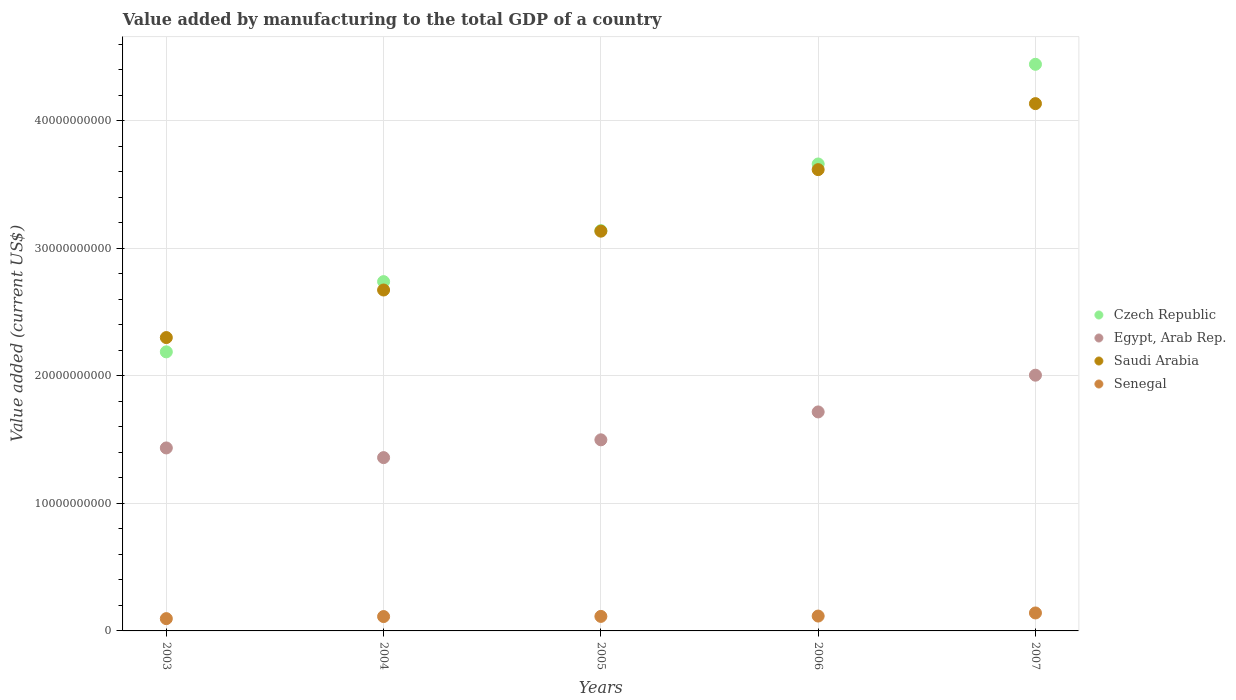What is the value added by manufacturing to the total GDP in Senegal in 2006?
Give a very brief answer. 1.17e+09. Across all years, what is the maximum value added by manufacturing to the total GDP in Senegal?
Provide a short and direct response. 1.41e+09. Across all years, what is the minimum value added by manufacturing to the total GDP in Czech Republic?
Make the answer very short. 2.19e+1. In which year was the value added by manufacturing to the total GDP in Czech Republic minimum?
Ensure brevity in your answer.  2003. What is the total value added by manufacturing to the total GDP in Senegal in the graph?
Offer a terse response. 5.80e+09. What is the difference between the value added by manufacturing to the total GDP in Saudi Arabia in 2003 and that in 2006?
Provide a succinct answer. -1.32e+1. What is the difference between the value added by manufacturing to the total GDP in Senegal in 2006 and the value added by manufacturing to the total GDP in Czech Republic in 2005?
Your answer should be compact. -3.02e+1. What is the average value added by manufacturing to the total GDP in Egypt, Arab Rep. per year?
Make the answer very short. 1.60e+1. In the year 2004, what is the difference between the value added by manufacturing to the total GDP in Egypt, Arab Rep. and value added by manufacturing to the total GDP in Czech Republic?
Your answer should be compact. -1.38e+1. In how many years, is the value added by manufacturing to the total GDP in Saudi Arabia greater than 30000000000 US$?
Your answer should be very brief. 3. What is the ratio of the value added by manufacturing to the total GDP in Egypt, Arab Rep. in 2005 to that in 2007?
Offer a very short reply. 0.75. Is the value added by manufacturing to the total GDP in Czech Republic in 2003 less than that in 2005?
Give a very brief answer. Yes. Is the difference between the value added by manufacturing to the total GDP in Egypt, Arab Rep. in 2004 and 2005 greater than the difference between the value added by manufacturing to the total GDP in Czech Republic in 2004 and 2005?
Offer a terse response. Yes. What is the difference between the highest and the second highest value added by manufacturing to the total GDP in Senegal?
Your response must be concise. 2.43e+08. What is the difference between the highest and the lowest value added by manufacturing to the total GDP in Saudi Arabia?
Your response must be concise. 1.83e+1. In how many years, is the value added by manufacturing to the total GDP in Saudi Arabia greater than the average value added by manufacturing to the total GDP in Saudi Arabia taken over all years?
Offer a terse response. 2. Is the sum of the value added by manufacturing to the total GDP in Senegal in 2003 and 2004 greater than the maximum value added by manufacturing to the total GDP in Egypt, Arab Rep. across all years?
Keep it short and to the point. No. Does the value added by manufacturing to the total GDP in Senegal monotonically increase over the years?
Your answer should be compact. Yes. Is the value added by manufacturing to the total GDP in Saudi Arabia strictly greater than the value added by manufacturing to the total GDP in Czech Republic over the years?
Give a very brief answer. No. Is the value added by manufacturing to the total GDP in Czech Republic strictly less than the value added by manufacturing to the total GDP in Saudi Arabia over the years?
Provide a short and direct response. No. Are the values on the major ticks of Y-axis written in scientific E-notation?
Provide a succinct answer. No. Does the graph contain any zero values?
Offer a very short reply. No. Does the graph contain grids?
Keep it short and to the point. Yes. Where does the legend appear in the graph?
Give a very brief answer. Center right. How are the legend labels stacked?
Keep it short and to the point. Vertical. What is the title of the graph?
Keep it short and to the point. Value added by manufacturing to the total GDP of a country. What is the label or title of the X-axis?
Provide a short and direct response. Years. What is the label or title of the Y-axis?
Make the answer very short. Value added (current US$). What is the Value added (current US$) of Czech Republic in 2003?
Your answer should be compact. 2.19e+1. What is the Value added (current US$) of Egypt, Arab Rep. in 2003?
Offer a terse response. 1.43e+1. What is the Value added (current US$) of Saudi Arabia in 2003?
Offer a terse response. 2.30e+1. What is the Value added (current US$) in Senegal in 2003?
Your response must be concise. 9.63e+08. What is the Value added (current US$) in Czech Republic in 2004?
Your response must be concise. 2.74e+1. What is the Value added (current US$) in Egypt, Arab Rep. in 2004?
Give a very brief answer. 1.36e+1. What is the Value added (current US$) in Saudi Arabia in 2004?
Provide a succinct answer. 2.67e+1. What is the Value added (current US$) in Senegal in 2004?
Provide a succinct answer. 1.13e+09. What is the Value added (current US$) of Czech Republic in 2005?
Keep it short and to the point. 3.14e+1. What is the Value added (current US$) in Egypt, Arab Rep. in 2005?
Your response must be concise. 1.50e+1. What is the Value added (current US$) in Saudi Arabia in 2005?
Provide a short and direct response. 3.13e+1. What is the Value added (current US$) in Senegal in 2005?
Ensure brevity in your answer.  1.14e+09. What is the Value added (current US$) of Czech Republic in 2006?
Offer a very short reply. 3.66e+1. What is the Value added (current US$) in Egypt, Arab Rep. in 2006?
Provide a succinct answer. 1.72e+1. What is the Value added (current US$) of Saudi Arabia in 2006?
Keep it short and to the point. 3.62e+1. What is the Value added (current US$) of Senegal in 2006?
Make the answer very short. 1.17e+09. What is the Value added (current US$) of Czech Republic in 2007?
Offer a very short reply. 4.44e+1. What is the Value added (current US$) in Egypt, Arab Rep. in 2007?
Keep it short and to the point. 2.01e+1. What is the Value added (current US$) in Saudi Arabia in 2007?
Your answer should be compact. 4.13e+1. What is the Value added (current US$) of Senegal in 2007?
Provide a short and direct response. 1.41e+09. Across all years, what is the maximum Value added (current US$) in Czech Republic?
Provide a short and direct response. 4.44e+1. Across all years, what is the maximum Value added (current US$) in Egypt, Arab Rep.?
Give a very brief answer. 2.01e+1. Across all years, what is the maximum Value added (current US$) in Saudi Arabia?
Your response must be concise. 4.13e+1. Across all years, what is the maximum Value added (current US$) of Senegal?
Keep it short and to the point. 1.41e+09. Across all years, what is the minimum Value added (current US$) in Czech Republic?
Make the answer very short. 2.19e+1. Across all years, what is the minimum Value added (current US$) of Egypt, Arab Rep.?
Give a very brief answer. 1.36e+1. Across all years, what is the minimum Value added (current US$) in Saudi Arabia?
Offer a very short reply. 2.30e+1. Across all years, what is the minimum Value added (current US$) in Senegal?
Your answer should be very brief. 9.63e+08. What is the total Value added (current US$) in Czech Republic in the graph?
Offer a terse response. 1.62e+11. What is the total Value added (current US$) in Egypt, Arab Rep. in the graph?
Your response must be concise. 8.02e+1. What is the total Value added (current US$) in Saudi Arabia in the graph?
Your answer should be compact. 1.59e+11. What is the total Value added (current US$) of Senegal in the graph?
Your answer should be very brief. 5.80e+09. What is the difference between the Value added (current US$) in Czech Republic in 2003 and that in 2004?
Make the answer very short. -5.51e+09. What is the difference between the Value added (current US$) of Egypt, Arab Rep. in 2003 and that in 2004?
Keep it short and to the point. 7.59e+08. What is the difference between the Value added (current US$) in Saudi Arabia in 2003 and that in 2004?
Provide a succinct answer. -3.73e+09. What is the difference between the Value added (current US$) of Senegal in 2003 and that in 2004?
Your answer should be very brief. -1.63e+08. What is the difference between the Value added (current US$) of Czech Republic in 2003 and that in 2005?
Offer a very short reply. -9.51e+09. What is the difference between the Value added (current US$) of Egypt, Arab Rep. in 2003 and that in 2005?
Offer a very short reply. -6.37e+08. What is the difference between the Value added (current US$) in Saudi Arabia in 2003 and that in 2005?
Your answer should be compact. -8.34e+09. What is the difference between the Value added (current US$) in Senegal in 2003 and that in 2005?
Your response must be concise. -1.75e+08. What is the difference between the Value added (current US$) of Czech Republic in 2003 and that in 2006?
Give a very brief answer. -1.47e+1. What is the difference between the Value added (current US$) of Egypt, Arab Rep. in 2003 and that in 2006?
Your answer should be compact. -2.82e+09. What is the difference between the Value added (current US$) in Saudi Arabia in 2003 and that in 2006?
Make the answer very short. -1.32e+1. What is the difference between the Value added (current US$) of Senegal in 2003 and that in 2006?
Your answer should be very brief. -2.03e+08. What is the difference between the Value added (current US$) of Czech Republic in 2003 and that in 2007?
Your response must be concise. -2.26e+1. What is the difference between the Value added (current US$) of Egypt, Arab Rep. in 2003 and that in 2007?
Provide a short and direct response. -5.71e+09. What is the difference between the Value added (current US$) of Saudi Arabia in 2003 and that in 2007?
Ensure brevity in your answer.  -1.83e+1. What is the difference between the Value added (current US$) in Senegal in 2003 and that in 2007?
Your answer should be compact. -4.45e+08. What is the difference between the Value added (current US$) of Czech Republic in 2004 and that in 2005?
Ensure brevity in your answer.  -4.00e+09. What is the difference between the Value added (current US$) of Egypt, Arab Rep. in 2004 and that in 2005?
Offer a terse response. -1.40e+09. What is the difference between the Value added (current US$) in Saudi Arabia in 2004 and that in 2005?
Provide a succinct answer. -4.61e+09. What is the difference between the Value added (current US$) of Senegal in 2004 and that in 2005?
Give a very brief answer. -1.24e+07. What is the difference between the Value added (current US$) of Czech Republic in 2004 and that in 2006?
Offer a very short reply. -9.23e+09. What is the difference between the Value added (current US$) of Egypt, Arab Rep. in 2004 and that in 2006?
Make the answer very short. -3.58e+09. What is the difference between the Value added (current US$) in Saudi Arabia in 2004 and that in 2006?
Give a very brief answer. -9.44e+09. What is the difference between the Value added (current US$) of Senegal in 2004 and that in 2006?
Provide a succinct answer. -3.95e+07. What is the difference between the Value added (current US$) of Czech Republic in 2004 and that in 2007?
Give a very brief answer. -1.70e+1. What is the difference between the Value added (current US$) in Egypt, Arab Rep. in 2004 and that in 2007?
Offer a very short reply. -6.46e+09. What is the difference between the Value added (current US$) in Saudi Arabia in 2004 and that in 2007?
Make the answer very short. -1.46e+1. What is the difference between the Value added (current US$) of Senegal in 2004 and that in 2007?
Make the answer very short. -2.82e+08. What is the difference between the Value added (current US$) in Czech Republic in 2005 and that in 2006?
Offer a terse response. -5.23e+09. What is the difference between the Value added (current US$) of Egypt, Arab Rep. in 2005 and that in 2006?
Offer a terse response. -2.19e+09. What is the difference between the Value added (current US$) of Saudi Arabia in 2005 and that in 2006?
Your answer should be very brief. -4.83e+09. What is the difference between the Value added (current US$) in Senegal in 2005 and that in 2006?
Keep it short and to the point. -2.71e+07. What is the difference between the Value added (current US$) in Czech Republic in 2005 and that in 2007?
Make the answer very short. -1.30e+1. What is the difference between the Value added (current US$) in Egypt, Arab Rep. in 2005 and that in 2007?
Offer a very short reply. -5.07e+09. What is the difference between the Value added (current US$) in Saudi Arabia in 2005 and that in 2007?
Keep it short and to the point. -1.00e+1. What is the difference between the Value added (current US$) of Senegal in 2005 and that in 2007?
Offer a very short reply. -2.70e+08. What is the difference between the Value added (current US$) of Czech Republic in 2006 and that in 2007?
Your answer should be compact. -7.82e+09. What is the difference between the Value added (current US$) in Egypt, Arab Rep. in 2006 and that in 2007?
Your answer should be compact. -2.88e+09. What is the difference between the Value added (current US$) in Saudi Arabia in 2006 and that in 2007?
Keep it short and to the point. -5.18e+09. What is the difference between the Value added (current US$) in Senegal in 2006 and that in 2007?
Provide a succinct answer. -2.43e+08. What is the difference between the Value added (current US$) of Czech Republic in 2003 and the Value added (current US$) of Egypt, Arab Rep. in 2004?
Your response must be concise. 8.29e+09. What is the difference between the Value added (current US$) of Czech Republic in 2003 and the Value added (current US$) of Saudi Arabia in 2004?
Ensure brevity in your answer.  -4.85e+09. What is the difference between the Value added (current US$) in Czech Republic in 2003 and the Value added (current US$) in Senegal in 2004?
Ensure brevity in your answer.  2.08e+1. What is the difference between the Value added (current US$) in Egypt, Arab Rep. in 2003 and the Value added (current US$) in Saudi Arabia in 2004?
Ensure brevity in your answer.  -1.24e+1. What is the difference between the Value added (current US$) in Egypt, Arab Rep. in 2003 and the Value added (current US$) in Senegal in 2004?
Keep it short and to the point. 1.32e+1. What is the difference between the Value added (current US$) of Saudi Arabia in 2003 and the Value added (current US$) of Senegal in 2004?
Ensure brevity in your answer.  2.19e+1. What is the difference between the Value added (current US$) in Czech Republic in 2003 and the Value added (current US$) in Egypt, Arab Rep. in 2005?
Provide a succinct answer. 6.90e+09. What is the difference between the Value added (current US$) in Czech Republic in 2003 and the Value added (current US$) in Saudi Arabia in 2005?
Provide a succinct answer. -9.47e+09. What is the difference between the Value added (current US$) in Czech Republic in 2003 and the Value added (current US$) in Senegal in 2005?
Your answer should be very brief. 2.07e+1. What is the difference between the Value added (current US$) of Egypt, Arab Rep. in 2003 and the Value added (current US$) of Saudi Arabia in 2005?
Your response must be concise. -1.70e+1. What is the difference between the Value added (current US$) in Egypt, Arab Rep. in 2003 and the Value added (current US$) in Senegal in 2005?
Provide a short and direct response. 1.32e+1. What is the difference between the Value added (current US$) in Saudi Arabia in 2003 and the Value added (current US$) in Senegal in 2005?
Offer a terse response. 2.19e+1. What is the difference between the Value added (current US$) in Czech Republic in 2003 and the Value added (current US$) in Egypt, Arab Rep. in 2006?
Offer a very short reply. 4.71e+09. What is the difference between the Value added (current US$) in Czech Republic in 2003 and the Value added (current US$) in Saudi Arabia in 2006?
Ensure brevity in your answer.  -1.43e+1. What is the difference between the Value added (current US$) of Czech Republic in 2003 and the Value added (current US$) of Senegal in 2006?
Provide a short and direct response. 2.07e+1. What is the difference between the Value added (current US$) in Egypt, Arab Rep. in 2003 and the Value added (current US$) in Saudi Arabia in 2006?
Keep it short and to the point. -2.18e+1. What is the difference between the Value added (current US$) in Egypt, Arab Rep. in 2003 and the Value added (current US$) in Senegal in 2006?
Your answer should be very brief. 1.32e+1. What is the difference between the Value added (current US$) in Saudi Arabia in 2003 and the Value added (current US$) in Senegal in 2006?
Your response must be concise. 2.18e+1. What is the difference between the Value added (current US$) of Czech Republic in 2003 and the Value added (current US$) of Egypt, Arab Rep. in 2007?
Your response must be concise. 1.83e+09. What is the difference between the Value added (current US$) in Czech Republic in 2003 and the Value added (current US$) in Saudi Arabia in 2007?
Provide a succinct answer. -1.95e+1. What is the difference between the Value added (current US$) of Czech Republic in 2003 and the Value added (current US$) of Senegal in 2007?
Make the answer very short. 2.05e+1. What is the difference between the Value added (current US$) of Egypt, Arab Rep. in 2003 and the Value added (current US$) of Saudi Arabia in 2007?
Ensure brevity in your answer.  -2.70e+1. What is the difference between the Value added (current US$) in Egypt, Arab Rep. in 2003 and the Value added (current US$) in Senegal in 2007?
Provide a short and direct response. 1.29e+1. What is the difference between the Value added (current US$) in Saudi Arabia in 2003 and the Value added (current US$) in Senegal in 2007?
Offer a terse response. 2.16e+1. What is the difference between the Value added (current US$) of Czech Republic in 2004 and the Value added (current US$) of Egypt, Arab Rep. in 2005?
Offer a very short reply. 1.24e+1. What is the difference between the Value added (current US$) in Czech Republic in 2004 and the Value added (current US$) in Saudi Arabia in 2005?
Offer a very short reply. -3.96e+09. What is the difference between the Value added (current US$) in Czech Republic in 2004 and the Value added (current US$) in Senegal in 2005?
Provide a short and direct response. 2.63e+1. What is the difference between the Value added (current US$) in Egypt, Arab Rep. in 2004 and the Value added (current US$) in Saudi Arabia in 2005?
Give a very brief answer. -1.78e+1. What is the difference between the Value added (current US$) of Egypt, Arab Rep. in 2004 and the Value added (current US$) of Senegal in 2005?
Offer a very short reply. 1.25e+1. What is the difference between the Value added (current US$) of Saudi Arabia in 2004 and the Value added (current US$) of Senegal in 2005?
Ensure brevity in your answer.  2.56e+1. What is the difference between the Value added (current US$) of Czech Republic in 2004 and the Value added (current US$) of Egypt, Arab Rep. in 2006?
Your answer should be very brief. 1.02e+1. What is the difference between the Value added (current US$) in Czech Republic in 2004 and the Value added (current US$) in Saudi Arabia in 2006?
Provide a succinct answer. -8.78e+09. What is the difference between the Value added (current US$) of Czech Republic in 2004 and the Value added (current US$) of Senegal in 2006?
Offer a very short reply. 2.62e+1. What is the difference between the Value added (current US$) in Egypt, Arab Rep. in 2004 and the Value added (current US$) in Saudi Arabia in 2006?
Ensure brevity in your answer.  -2.26e+1. What is the difference between the Value added (current US$) in Egypt, Arab Rep. in 2004 and the Value added (current US$) in Senegal in 2006?
Your answer should be compact. 1.24e+1. What is the difference between the Value added (current US$) in Saudi Arabia in 2004 and the Value added (current US$) in Senegal in 2006?
Your answer should be very brief. 2.56e+1. What is the difference between the Value added (current US$) in Czech Republic in 2004 and the Value added (current US$) in Egypt, Arab Rep. in 2007?
Give a very brief answer. 7.34e+09. What is the difference between the Value added (current US$) of Czech Republic in 2004 and the Value added (current US$) of Saudi Arabia in 2007?
Keep it short and to the point. -1.40e+1. What is the difference between the Value added (current US$) in Czech Republic in 2004 and the Value added (current US$) in Senegal in 2007?
Keep it short and to the point. 2.60e+1. What is the difference between the Value added (current US$) in Egypt, Arab Rep. in 2004 and the Value added (current US$) in Saudi Arabia in 2007?
Provide a short and direct response. -2.78e+1. What is the difference between the Value added (current US$) of Egypt, Arab Rep. in 2004 and the Value added (current US$) of Senegal in 2007?
Your answer should be compact. 1.22e+1. What is the difference between the Value added (current US$) of Saudi Arabia in 2004 and the Value added (current US$) of Senegal in 2007?
Your answer should be compact. 2.53e+1. What is the difference between the Value added (current US$) in Czech Republic in 2005 and the Value added (current US$) in Egypt, Arab Rep. in 2006?
Your response must be concise. 1.42e+1. What is the difference between the Value added (current US$) of Czech Republic in 2005 and the Value added (current US$) of Saudi Arabia in 2006?
Offer a very short reply. -4.78e+09. What is the difference between the Value added (current US$) of Czech Republic in 2005 and the Value added (current US$) of Senegal in 2006?
Your answer should be very brief. 3.02e+1. What is the difference between the Value added (current US$) of Egypt, Arab Rep. in 2005 and the Value added (current US$) of Saudi Arabia in 2006?
Offer a terse response. -2.12e+1. What is the difference between the Value added (current US$) in Egypt, Arab Rep. in 2005 and the Value added (current US$) in Senegal in 2006?
Offer a terse response. 1.38e+1. What is the difference between the Value added (current US$) of Saudi Arabia in 2005 and the Value added (current US$) of Senegal in 2006?
Ensure brevity in your answer.  3.02e+1. What is the difference between the Value added (current US$) in Czech Republic in 2005 and the Value added (current US$) in Egypt, Arab Rep. in 2007?
Offer a terse response. 1.13e+1. What is the difference between the Value added (current US$) of Czech Republic in 2005 and the Value added (current US$) of Saudi Arabia in 2007?
Ensure brevity in your answer.  -9.96e+09. What is the difference between the Value added (current US$) in Czech Republic in 2005 and the Value added (current US$) in Senegal in 2007?
Offer a terse response. 3.00e+1. What is the difference between the Value added (current US$) of Egypt, Arab Rep. in 2005 and the Value added (current US$) of Saudi Arabia in 2007?
Your answer should be compact. -2.64e+1. What is the difference between the Value added (current US$) of Egypt, Arab Rep. in 2005 and the Value added (current US$) of Senegal in 2007?
Your answer should be very brief. 1.36e+1. What is the difference between the Value added (current US$) in Saudi Arabia in 2005 and the Value added (current US$) in Senegal in 2007?
Provide a succinct answer. 2.99e+1. What is the difference between the Value added (current US$) of Czech Republic in 2006 and the Value added (current US$) of Egypt, Arab Rep. in 2007?
Your answer should be compact. 1.66e+1. What is the difference between the Value added (current US$) in Czech Republic in 2006 and the Value added (current US$) in Saudi Arabia in 2007?
Your answer should be compact. -4.73e+09. What is the difference between the Value added (current US$) of Czech Republic in 2006 and the Value added (current US$) of Senegal in 2007?
Your answer should be compact. 3.52e+1. What is the difference between the Value added (current US$) of Egypt, Arab Rep. in 2006 and the Value added (current US$) of Saudi Arabia in 2007?
Offer a terse response. -2.42e+1. What is the difference between the Value added (current US$) of Egypt, Arab Rep. in 2006 and the Value added (current US$) of Senegal in 2007?
Offer a terse response. 1.58e+1. What is the difference between the Value added (current US$) in Saudi Arabia in 2006 and the Value added (current US$) in Senegal in 2007?
Your answer should be very brief. 3.48e+1. What is the average Value added (current US$) of Czech Republic per year?
Your answer should be very brief. 3.23e+1. What is the average Value added (current US$) in Egypt, Arab Rep. per year?
Make the answer very short. 1.60e+1. What is the average Value added (current US$) of Saudi Arabia per year?
Keep it short and to the point. 3.17e+1. What is the average Value added (current US$) of Senegal per year?
Keep it short and to the point. 1.16e+09. In the year 2003, what is the difference between the Value added (current US$) in Czech Republic and Value added (current US$) in Egypt, Arab Rep.?
Give a very brief answer. 7.53e+09. In the year 2003, what is the difference between the Value added (current US$) in Czech Republic and Value added (current US$) in Saudi Arabia?
Ensure brevity in your answer.  -1.12e+09. In the year 2003, what is the difference between the Value added (current US$) of Czech Republic and Value added (current US$) of Senegal?
Your answer should be compact. 2.09e+1. In the year 2003, what is the difference between the Value added (current US$) in Egypt, Arab Rep. and Value added (current US$) in Saudi Arabia?
Keep it short and to the point. -8.66e+09. In the year 2003, what is the difference between the Value added (current US$) of Egypt, Arab Rep. and Value added (current US$) of Senegal?
Your response must be concise. 1.34e+1. In the year 2003, what is the difference between the Value added (current US$) in Saudi Arabia and Value added (current US$) in Senegal?
Provide a short and direct response. 2.20e+1. In the year 2004, what is the difference between the Value added (current US$) in Czech Republic and Value added (current US$) in Egypt, Arab Rep.?
Your response must be concise. 1.38e+1. In the year 2004, what is the difference between the Value added (current US$) in Czech Republic and Value added (current US$) in Saudi Arabia?
Your answer should be very brief. 6.57e+08. In the year 2004, what is the difference between the Value added (current US$) of Czech Republic and Value added (current US$) of Senegal?
Keep it short and to the point. 2.63e+1. In the year 2004, what is the difference between the Value added (current US$) in Egypt, Arab Rep. and Value added (current US$) in Saudi Arabia?
Your answer should be compact. -1.31e+1. In the year 2004, what is the difference between the Value added (current US$) of Egypt, Arab Rep. and Value added (current US$) of Senegal?
Your response must be concise. 1.25e+1. In the year 2004, what is the difference between the Value added (current US$) of Saudi Arabia and Value added (current US$) of Senegal?
Provide a short and direct response. 2.56e+1. In the year 2005, what is the difference between the Value added (current US$) of Czech Republic and Value added (current US$) of Egypt, Arab Rep.?
Offer a terse response. 1.64e+1. In the year 2005, what is the difference between the Value added (current US$) in Czech Republic and Value added (current US$) in Saudi Arabia?
Your answer should be compact. 4.11e+07. In the year 2005, what is the difference between the Value added (current US$) of Czech Republic and Value added (current US$) of Senegal?
Make the answer very short. 3.03e+1. In the year 2005, what is the difference between the Value added (current US$) in Egypt, Arab Rep. and Value added (current US$) in Saudi Arabia?
Offer a terse response. -1.64e+1. In the year 2005, what is the difference between the Value added (current US$) of Egypt, Arab Rep. and Value added (current US$) of Senegal?
Your response must be concise. 1.38e+1. In the year 2005, what is the difference between the Value added (current US$) of Saudi Arabia and Value added (current US$) of Senegal?
Offer a very short reply. 3.02e+1. In the year 2006, what is the difference between the Value added (current US$) in Czech Republic and Value added (current US$) in Egypt, Arab Rep.?
Offer a terse response. 1.94e+1. In the year 2006, what is the difference between the Value added (current US$) of Czech Republic and Value added (current US$) of Saudi Arabia?
Your answer should be very brief. 4.44e+08. In the year 2006, what is the difference between the Value added (current US$) in Czech Republic and Value added (current US$) in Senegal?
Your response must be concise. 3.55e+1. In the year 2006, what is the difference between the Value added (current US$) in Egypt, Arab Rep. and Value added (current US$) in Saudi Arabia?
Your answer should be compact. -1.90e+1. In the year 2006, what is the difference between the Value added (current US$) of Egypt, Arab Rep. and Value added (current US$) of Senegal?
Your response must be concise. 1.60e+1. In the year 2006, what is the difference between the Value added (current US$) in Saudi Arabia and Value added (current US$) in Senegal?
Ensure brevity in your answer.  3.50e+1. In the year 2007, what is the difference between the Value added (current US$) of Czech Republic and Value added (current US$) of Egypt, Arab Rep.?
Your answer should be very brief. 2.44e+1. In the year 2007, what is the difference between the Value added (current US$) in Czech Republic and Value added (current US$) in Saudi Arabia?
Your answer should be very brief. 3.09e+09. In the year 2007, what is the difference between the Value added (current US$) of Czech Republic and Value added (current US$) of Senegal?
Offer a terse response. 4.30e+1. In the year 2007, what is the difference between the Value added (current US$) of Egypt, Arab Rep. and Value added (current US$) of Saudi Arabia?
Your response must be concise. -2.13e+1. In the year 2007, what is the difference between the Value added (current US$) in Egypt, Arab Rep. and Value added (current US$) in Senegal?
Make the answer very short. 1.86e+1. In the year 2007, what is the difference between the Value added (current US$) in Saudi Arabia and Value added (current US$) in Senegal?
Give a very brief answer. 3.99e+1. What is the ratio of the Value added (current US$) in Czech Republic in 2003 to that in 2004?
Give a very brief answer. 0.8. What is the ratio of the Value added (current US$) in Egypt, Arab Rep. in 2003 to that in 2004?
Your answer should be compact. 1.06. What is the ratio of the Value added (current US$) in Saudi Arabia in 2003 to that in 2004?
Your answer should be very brief. 0.86. What is the ratio of the Value added (current US$) of Senegal in 2003 to that in 2004?
Your response must be concise. 0.86. What is the ratio of the Value added (current US$) in Czech Republic in 2003 to that in 2005?
Make the answer very short. 0.7. What is the ratio of the Value added (current US$) of Egypt, Arab Rep. in 2003 to that in 2005?
Give a very brief answer. 0.96. What is the ratio of the Value added (current US$) of Saudi Arabia in 2003 to that in 2005?
Offer a very short reply. 0.73. What is the ratio of the Value added (current US$) of Senegal in 2003 to that in 2005?
Your answer should be very brief. 0.85. What is the ratio of the Value added (current US$) in Czech Republic in 2003 to that in 2006?
Provide a short and direct response. 0.6. What is the ratio of the Value added (current US$) of Egypt, Arab Rep. in 2003 to that in 2006?
Make the answer very short. 0.84. What is the ratio of the Value added (current US$) of Saudi Arabia in 2003 to that in 2006?
Your response must be concise. 0.64. What is the ratio of the Value added (current US$) of Senegal in 2003 to that in 2006?
Offer a very short reply. 0.83. What is the ratio of the Value added (current US$) in Czech Republic in 2003 to that in 2007?
Your answer should be very brief. 0.49. What is the ratio of the Value added (current US$) of Egypt, Arab Rep. in 2003 to that in 2007?
Make the answer very short. 0.72. What is the ratio of the Value added (current US$) in Saudi Arabia in 2003 to that in 2007?
Your answer should be very brief. 0.56. What is the ratio of the Value added (current US$) of Senegal in 2003 to that in 2007?
Give a very brief answer. 0.68. What is the ratio of the Value added (current US$) of Czech Republic in 2004 to that in 2005?
Your answer should be compact. 0.87. What is the ratio of the Value added (current US$) of Egypt, Arab Rep. in 2004 to that in 2005?
Provide a succinct answer. 0.91. What is the ratio of the Value added (current US$) in Saudi Arabia in 2004 to that in 2005?
Provide a short and direct response. 0.85. What is the ratio of the Value added (current US$) in Czech Republic in 2004 to that in 2006?
Ensure brevity in your answer.  0.75. What is the ratio of the Value added (current US$) in Egypt, Arab Rep. in 2004 to that in 2006?
Offer a very short reply. 0.79. What is the ratio of the Value added (current US$) of Saudi Arabia in 2004 to that in 2006?
Keep it short and to the point. 0.74. What is the ratio of the Value added (current US$) of Senegal in 2004 to that in 2006?
Keep it short and to the point. 0.97. What is the ratio of the Value added (current US$) in Czech Republic in 2004 to that in 2007?
Offer a very short reply. 0.62. What is the ratio of the Value added (current US$) in Egypt, Arab Rep. in 2004 to that in 2007?
Your response must be concise. 0.68. What is the ratio of the Value added (current US$) in Saudi Arabia in 2004 to that in 2007?
Offer a terse response. 0.65. What is the ratio of the Value added (current US$) of Senegal in 2004 to that in 2007?
Your answer should be very brief. 0.8. What is the ratio of the Value added (current US$) in Czech Republic in 2005 to that in 2006?
Your answer should be compact. 0.86. What is the ratio of the Value added (current US$) in Egypt, Arab Rep. in 2005 to that in 2006?
Give a very brief answer. 0.87. What is the ratio of the Value added (current US$) in Saudi Arabia in 2005 to that in 2006?
Give a very brief answer. 0.87. What is the ratio of the Value added (current US$) of Senegal in 2005 to that in 2006?
Your answer should be very brief. 0.98. What is the ratio of the Value added (current US$) in Czech Republic in 2005 to that in 2007?
Your answer should be very brief. 0.71. What is the ratio of the Value added (current US$) in Egypt, Arab Rep. in 2005 to that in 2007?
Make the answer very short. 0.75. What is the ratio of the Value added (current US$) of Saudi Arabia in 2005 to that in 2007?
Ensure brevity in your answer.  0.76. What is the ratio of the Value added (current US$) in Senegal in 2005 to that in 2007?
Keep it short and to the point. 0.81. What is the ratio of the Value added (current US$) in Czech Republic in 2006 to that in 2007?
Make the answer very short. 0.82. What is the ratio of the Value added (current US$) in Egypt, Arab Rep. in 2006 to that in 2007?
Offer a very short reply. 0.86. What is the ratio of the Value added (current US$) in Saudi Arabia in 2006 to that in 2007?
Offer a very short reply. 0.87. What is the ratio of the Value added (current US$) in Senegal in 2006 to that in 2007?
Make the answer very short. 0.83. What is the difference between the highest and the second highest Value added (current US$) of Czech Republic?
Ensure brevity in your answer.  7.82e+09. What is the difference between the highest and the second highest Value added (current US$) in Egypt, Arab Rep.?
Your response must be concise. 2.88e+09. What is the difference between the highest and the second highest Value added (current US$) in Saudi Arabia?
Provide a short and direct response. 5.18e+09. What is the difference between the highest and the second highest Value added (current US$) of Senegal?
Make the answer very short. 2.43e+08. What is the difference between the highest and the lowest Value added (current US$) of Czech Republic?
Give a very brief answer. 2.26e+1. What is the difference between the highest and the lowest Value added (current US$) of Egypt, Arab Rep.?
Your answer should be compact. 6.46e+09. What is the difference between the highest and the lowest Value added (current US$) in Saudi Arabia?
Your response must be concise. 1.83e+1. What is the difference between the highest and the lowest Value added (current US$) in Senegal?
Your answer should be very brief. 4.45e+08. 